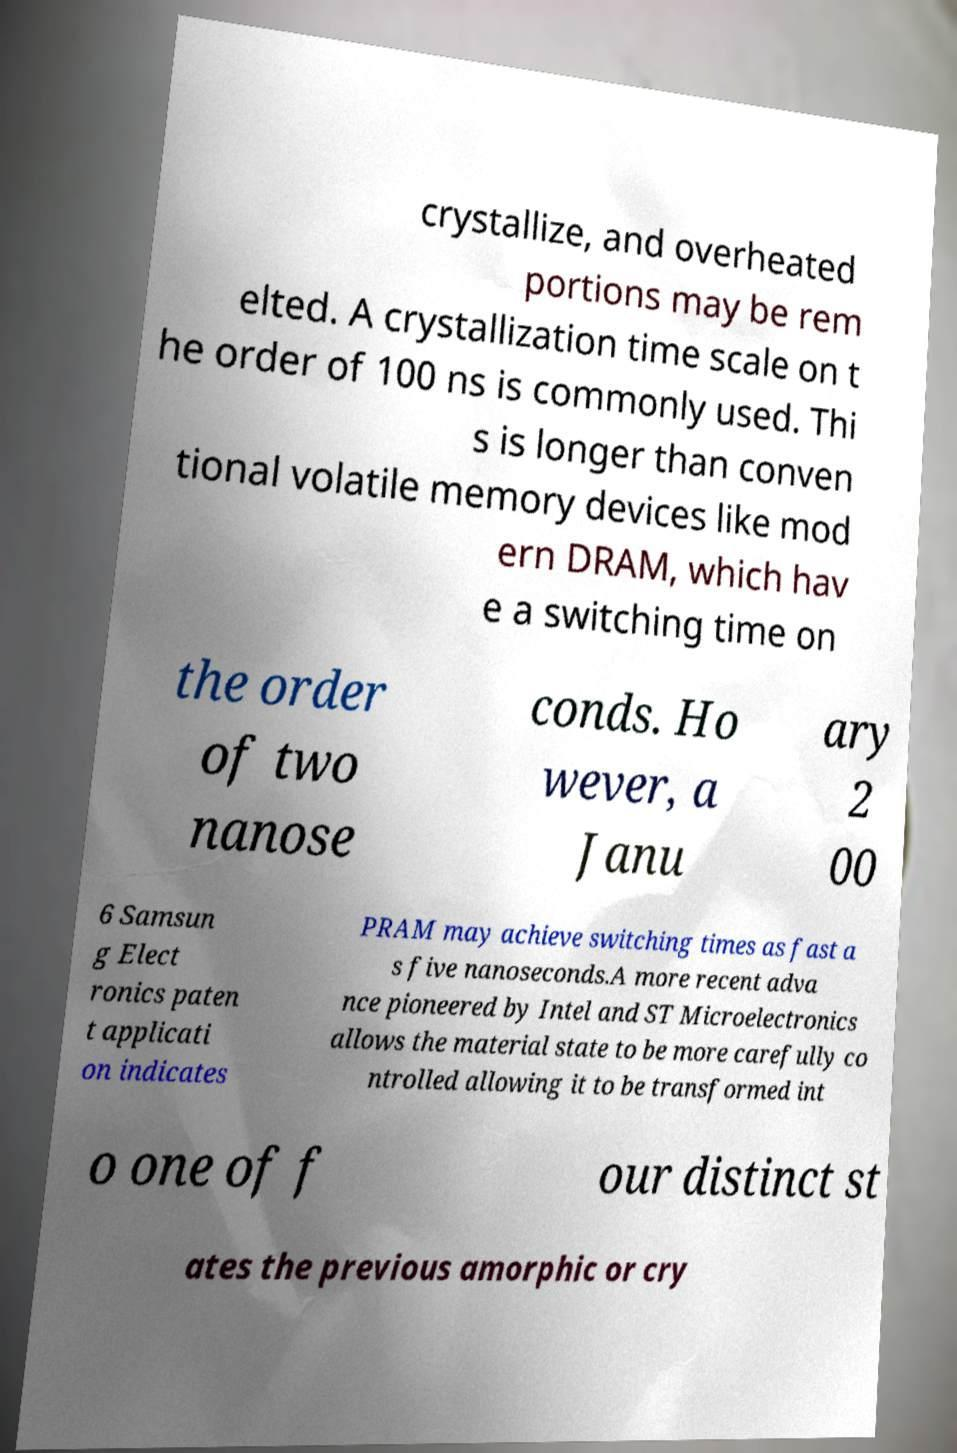Can you accurately transcribe the text from the provided image for me? crystallize, and overheated portions may be rem elted. A crystallization time scale on t he order of 100 ns is commonly used. Thi s is longer than conven tional volatile memory devices like mod ern DRAM, which hav e a switching time on the order of two nanose conds. Ho wever, a Janu ary 2 00 6 Samsun g Elect ronics paten t applicati on indicates PRAM may achieve switching times as fast a s five nanoseconds.A more recent adva nce pioneered by Intel and ST Microelectronics allows the material state to be more carefully co ntrolled allowing it to be transformed int o one of f our distinct st ates the previous amorphic or cry 